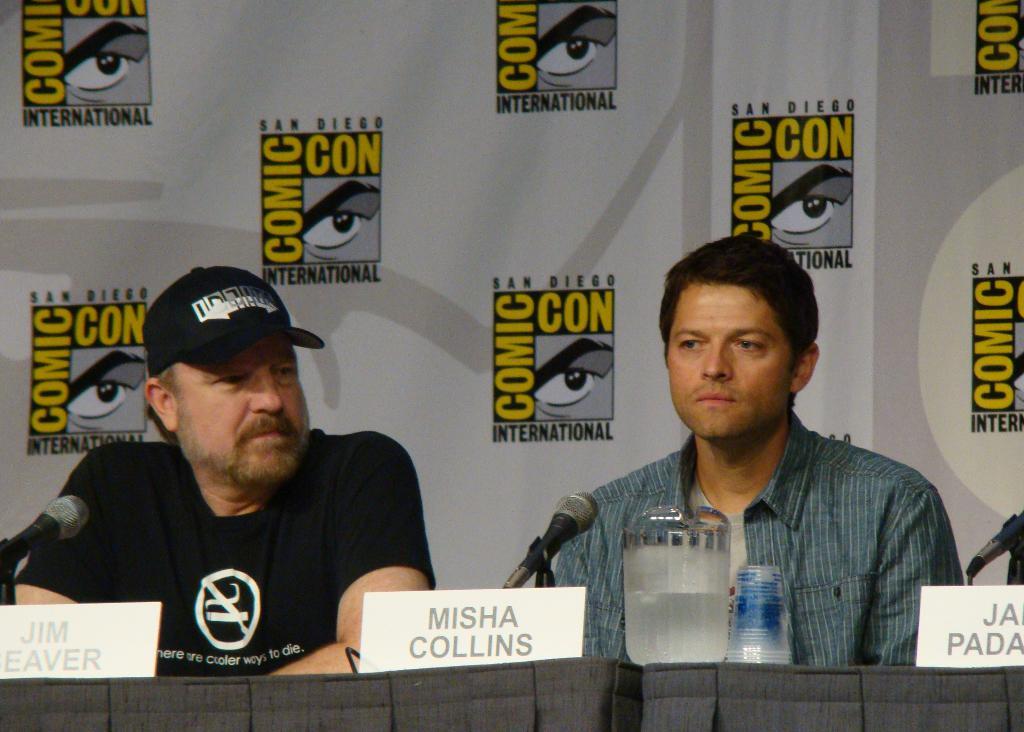What convention is this?
Give a very brief answer. Comic con. 